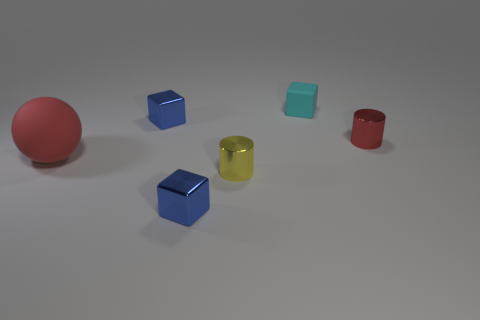Are there the same number of blue objects behind the small red shiny cylinder and things that are on the right side of the small cyan rubber cube?
Provide a succinct answer. Yes. There is a small cylinder to the right of the small shiny cylinder to the left of the tiny matte thing; what is it made of?
Give a very brief answer. Metal. What number of objects are small brown shiny blocks or red objects behind the big red thing?
Provide a succinct answer. 1. What size is the block that is made of the same material as the big thing?
Give a very brief answer. Small. Are there more small cylinders that are in front of the red metallic cylinder than green metallic cylinders?
Keep it short and to the point. Yes. How big is the cube that is behind the small yellow cylinder and to the left of the small yellow cylinder?
Ensure brevity in your answer.  Small. There is another thing that is the same shape as the red metal thing; what material is it?
Your response must be concise. Metal. There is a blue metal block that is in front of the red cylinder; does it have the same size as the red shiny object?
Ensure brevity in your answer.  Yes. What color is the small thing that is to the left of the yellow metallic object and behind the big red ball?
Your response must be concise. Blue. How many blue things are left of the small blue thing behind the small red object?
Offer a very short reply. 0. 